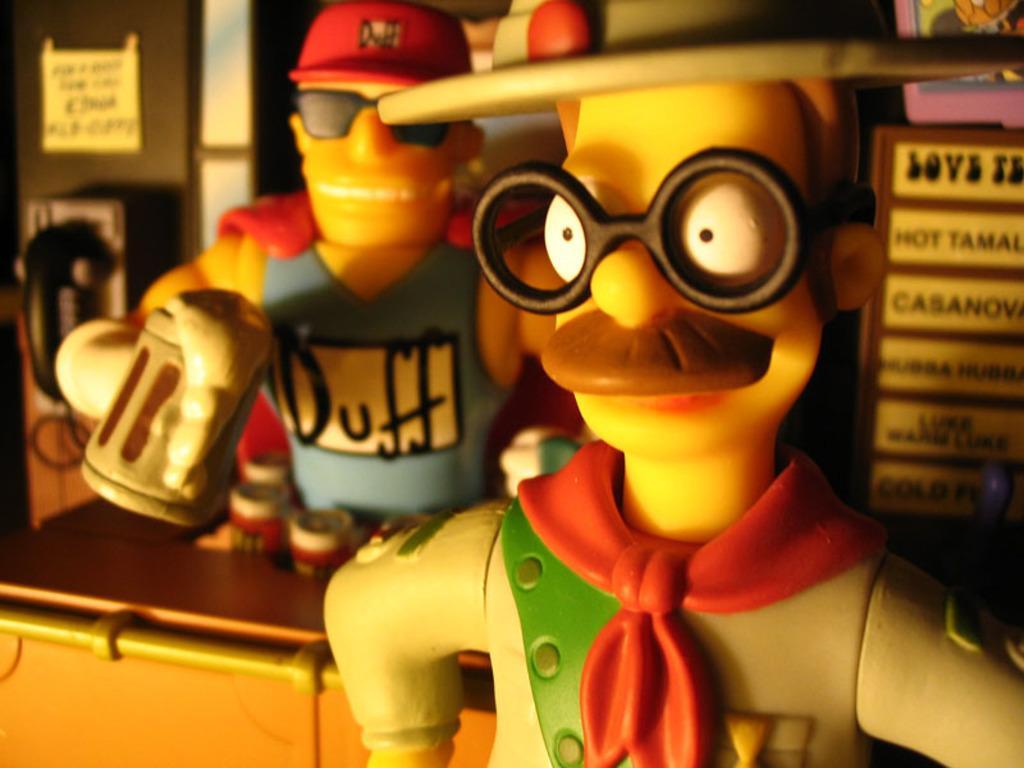Could you give a brief overview of what you see in this image? In this image I can see few toys in different colors and few objects on the table. Back I can see a telephone. 